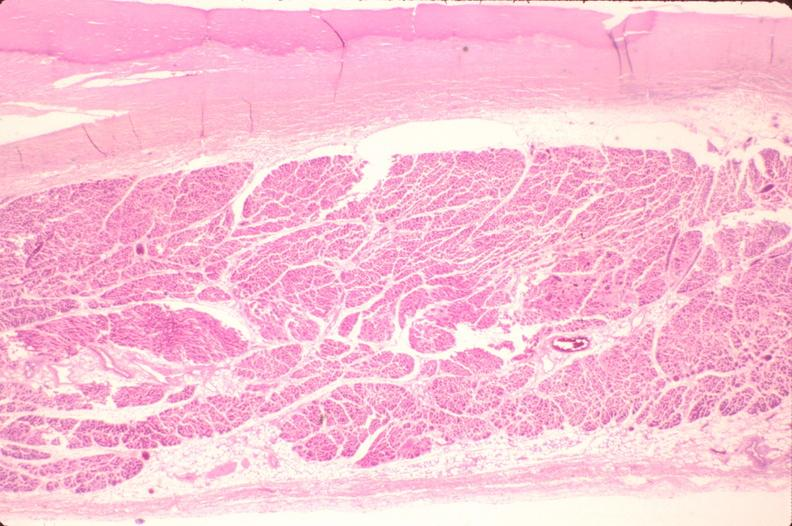does metastatic carcinoma prostate show heart, fibrosis, chronic rheumatic heart disease?
Answer the question using a single word or phrase. No 